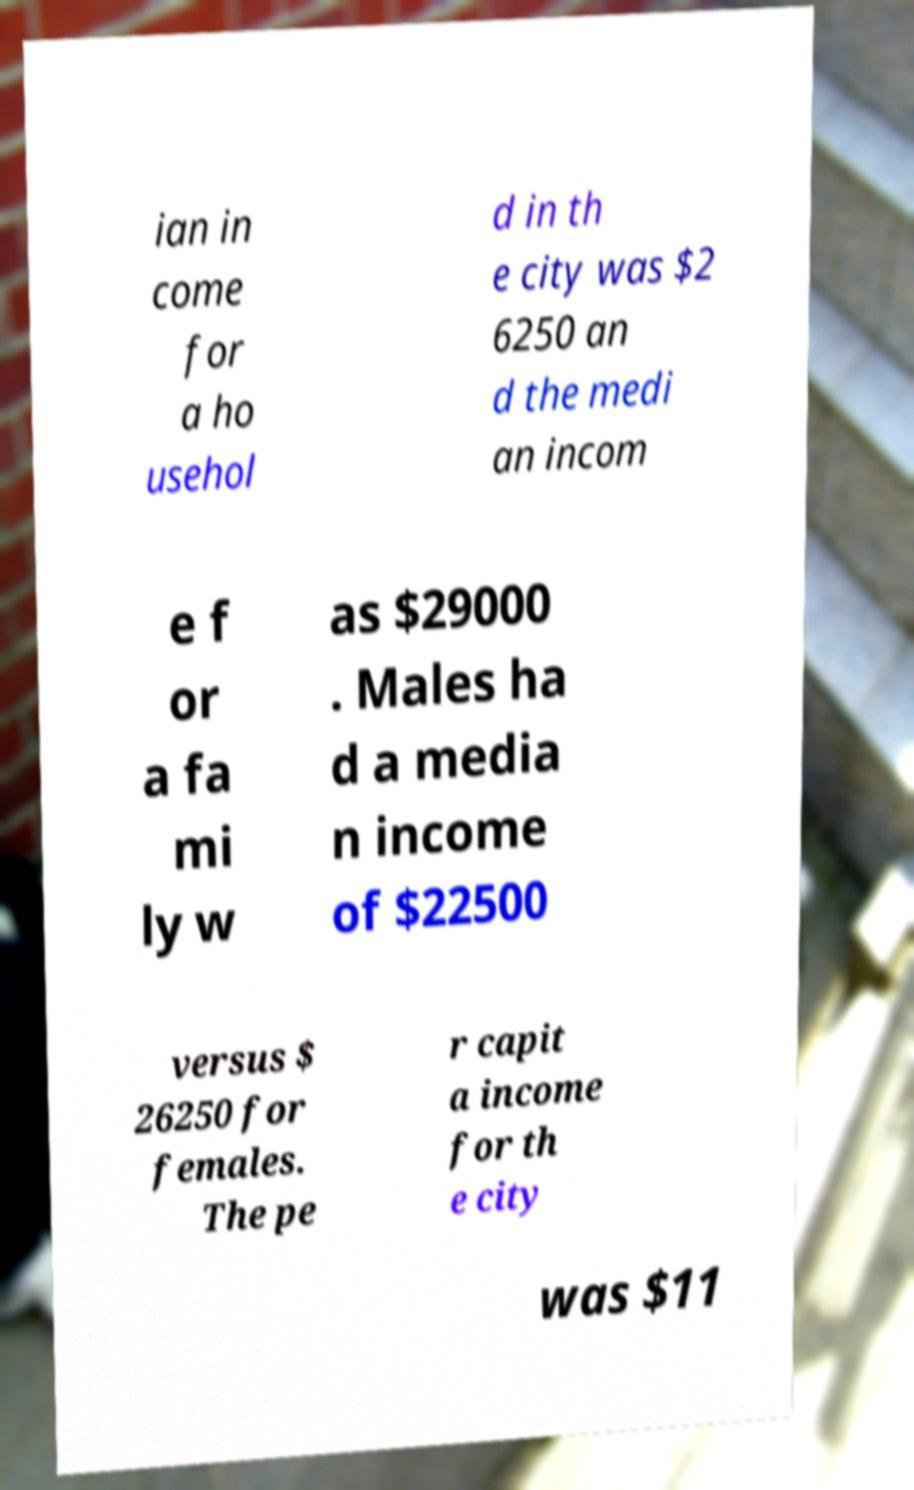Please read and relay the text visible in this image. What does it say? ian in come for a ho usehol d in th e city was $2 6250 an d the medi an incom e f or a fa mi ly w as $29000 . Males ha d a media n income of $22500 versus $ 26250 for females. The pe r capit a income for th e city was $11 